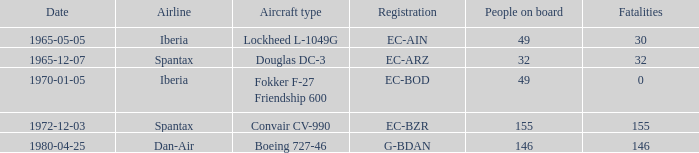Could you parse the entire table as a dict? {'header': ['Date', 'Airline', 'Aircraft type', 'Registration', 'People on board', 'Fatalities'], 'rows': [['1965-05-05', 'Iberia', 'Lockheed L-1049G', 'EC-AIN', '49', '30'], ['1965-12-07', 'Spantax', 'Douglas DC-3', 'EC-ARZ', '32', '32'], ['1970-01-05', 'Iberia', 'Fokker F-27 Friendship 600', 'EC-BOD', '49', '0'], ['1972-12-03', 'Spantax', 'Convair CV-990', 'EC-BZR', '155', '155'], ['1980-04-25', 'Dan-Air', 'Boeing 727-46', 'G-BDAN', '146', '146']]} What is the passenger count on iberia airline's lockheed l-1049g airplane? 49.0. 